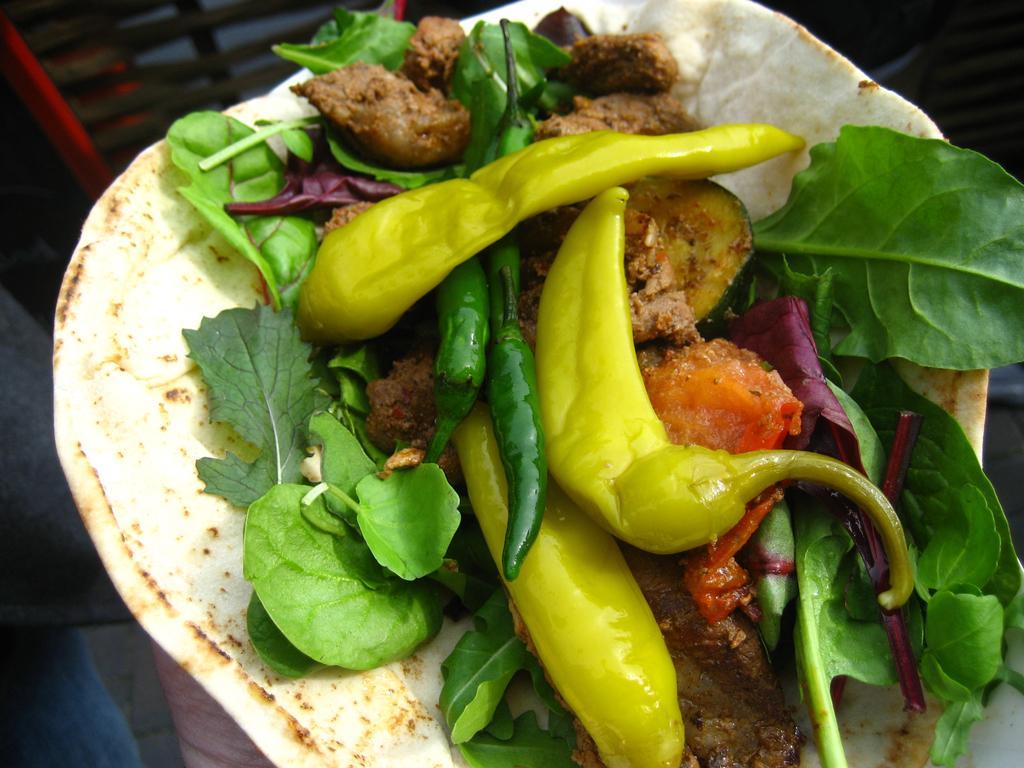Please provide a concise description of this image. In this picture we can see food and blurry background. 